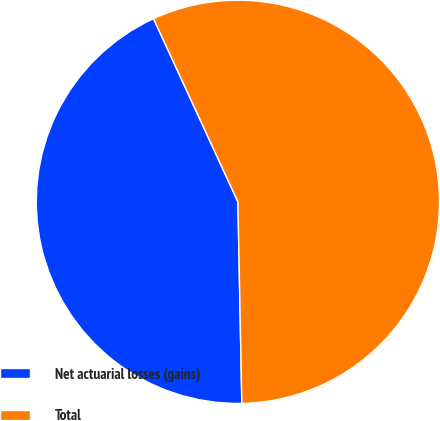Convert chart. <chart><loc_0><loc_0><loc_500><loc_500><pie_chart><fcel>Net actuarial losses (gains)<fcel>Total<nl><fcel>43.44%<fcel>56.56%<nl></chart> 